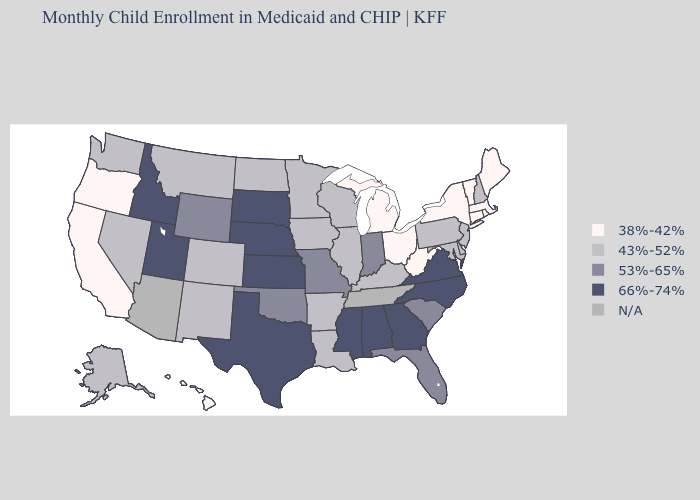Does Massachusetts have the lowest value in the USA?
Concise answer only. Yes. Name the states that have a value in the range 66%-74%?
Concise answer only. Alabama, Georgia, Idaho, Kansas, Mississippi, Nebraska, North Carolina, South Dakota, Texas, Utah, Virginia. What is the value of Wisconsin?
Concise answer only. 43%-52%. What is the value of Vermont?
Keep it brief. 38%-42%. What is the highest value in states that border Oregon?
Answer briefly. 66%-74%. What is the value of South Carolina?
Keep it brief. 53%-65%. Among the states that border Vermont , does New Hampshire have the lowest value?
Be succinct. No. What is the value of Connecticut?
Give a very brief answer. 38%-42%. What is the value of Massachusetts?
Give a very brief answer. 38%-42%. What is the highest value in the USA?
Quick response, please. 66%-74%. What is the value of Maryland?
Keep it brief. 43%-52%. 